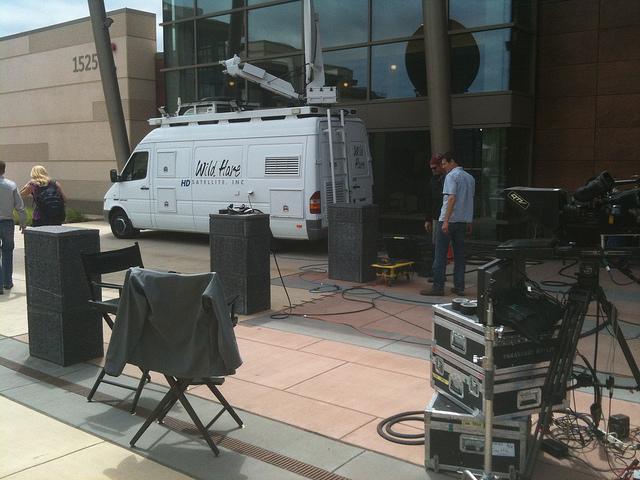Are there any windows in the picture?
Give a very brief answer. Yes. What numbers are on the building?
Quick response, please. 1525. How many bikes are there?
Write a very short answer. 0. How many chairs are there?
Keep it brief. 2. What name is on the truck?
Give a very brief answer. Wild hare. Is this an older photo?
Write a very short answer. No. How big is the truck?
Short answer required. Medium. What vehicle is this?
Short answer required. Van. What is the woman on the left wearing on her back?
Quick response, please. Backpack. 